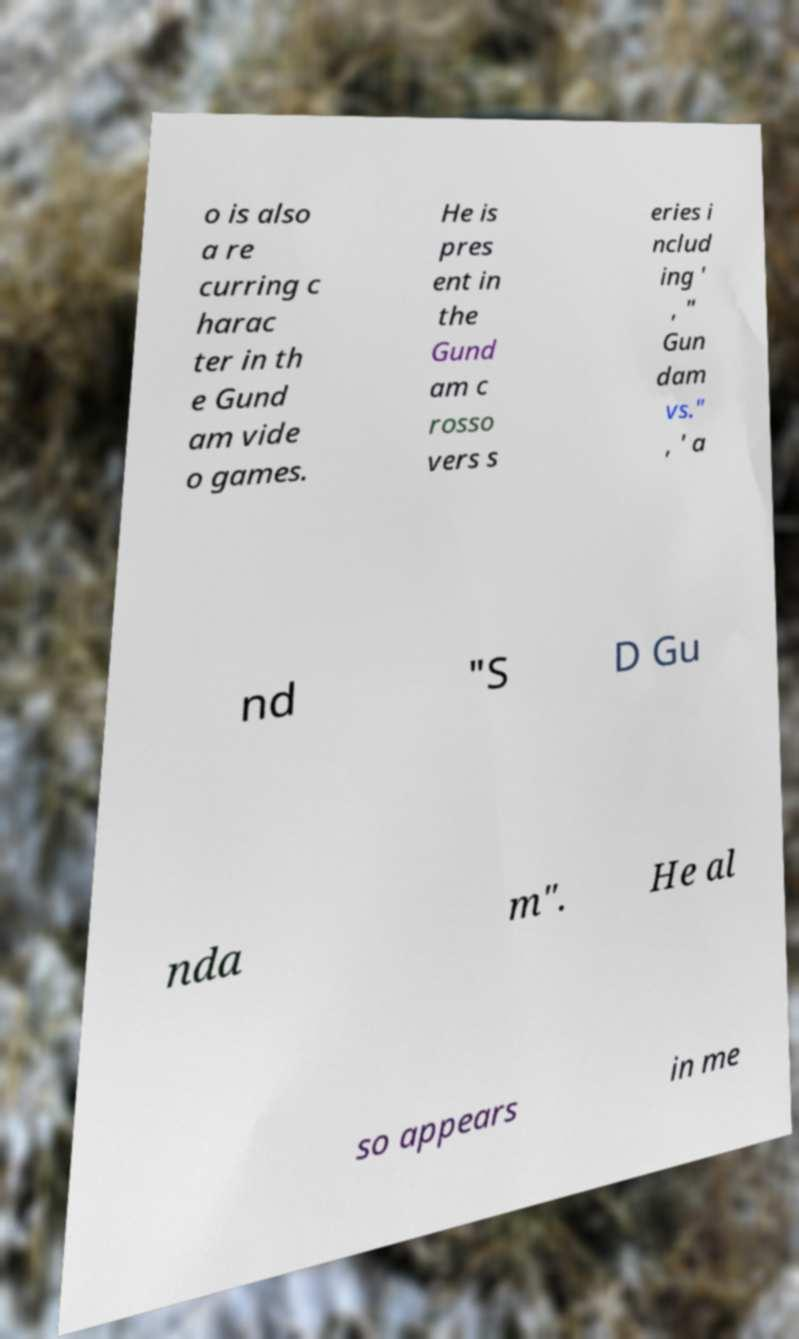Please identify and transcribe the text found in this image. o is also a re curring c harac ter in th e Gund am vide o games. He is pres ent in the Gund am c rosso vers s eries i nclud ing ' , " Gun dam vs." , ' a nd "S D Gu nda m". He al so appears in me 